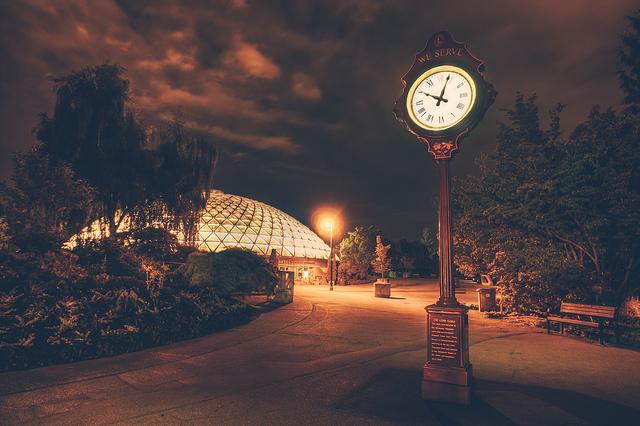What does the clock say?
Short answer required. 10:05. What style of building is in the background?
Keep it brief. Dome. What time is it?
Keep it brief. 10:05. How many clock faces are there?
Quick response, please. 1. 